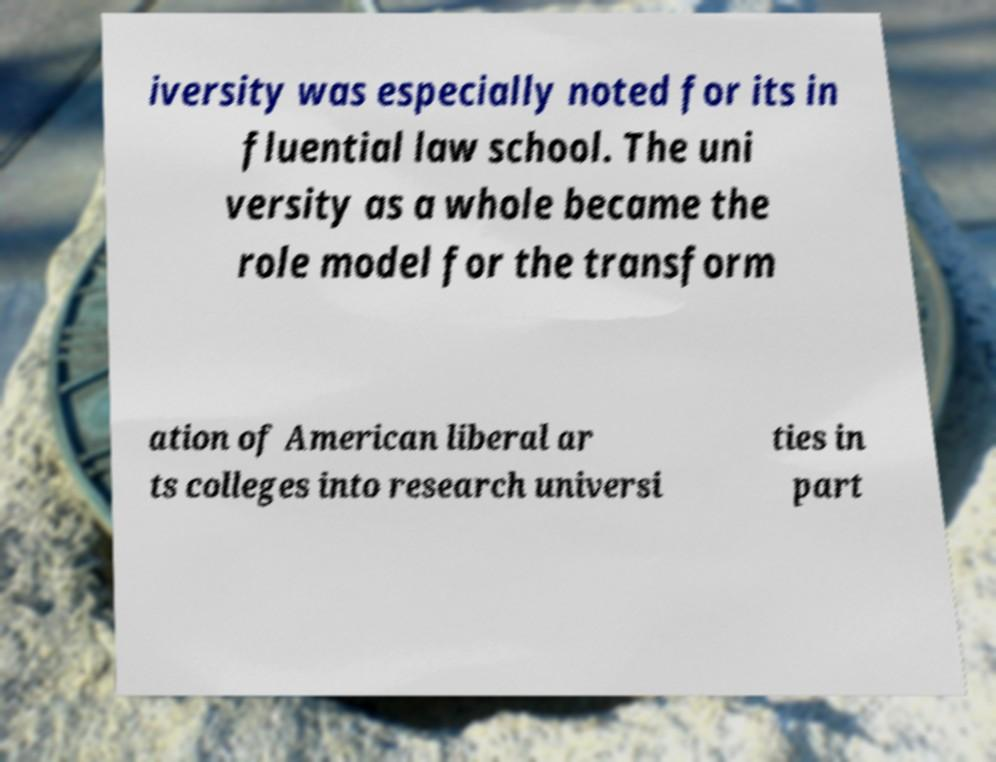Can you read and provide the text displayed in the image?This photo seems to have some interesting text. Can you extract and type it out for me? iversity was especially noted for its in fluential law school. The uni versity as a whole became the role model for the transform ation of American liberal ar ts colleges into research universi ties in part 